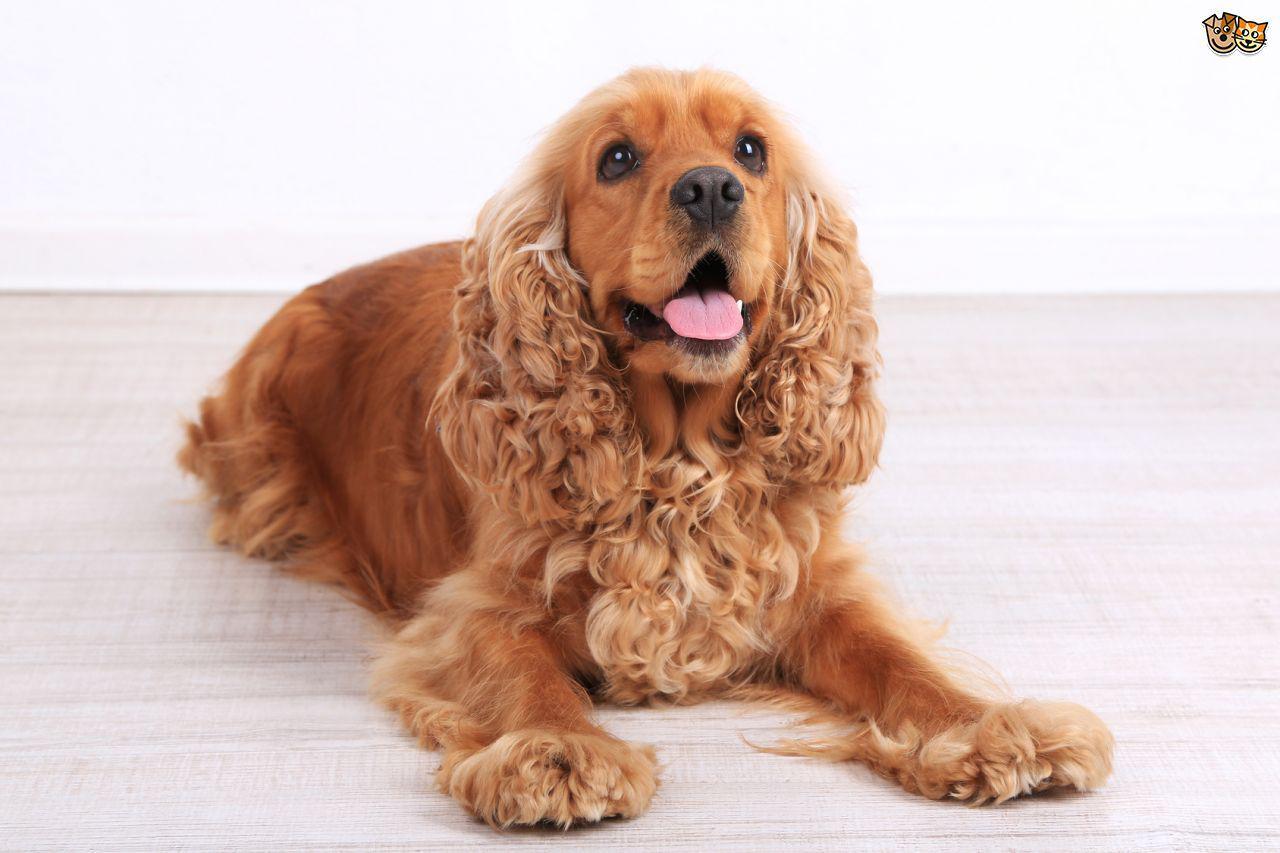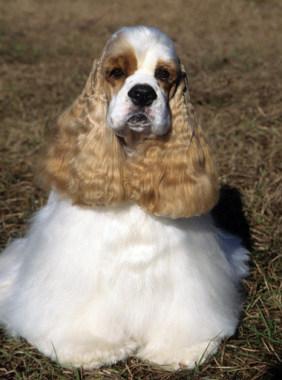The first image is the image on the left, the second image is the image on the right. Given the left and right images, does the statement "Together, the two images show a puppy and a full-grown spaniel." hold true? Answer yes or no. No. 